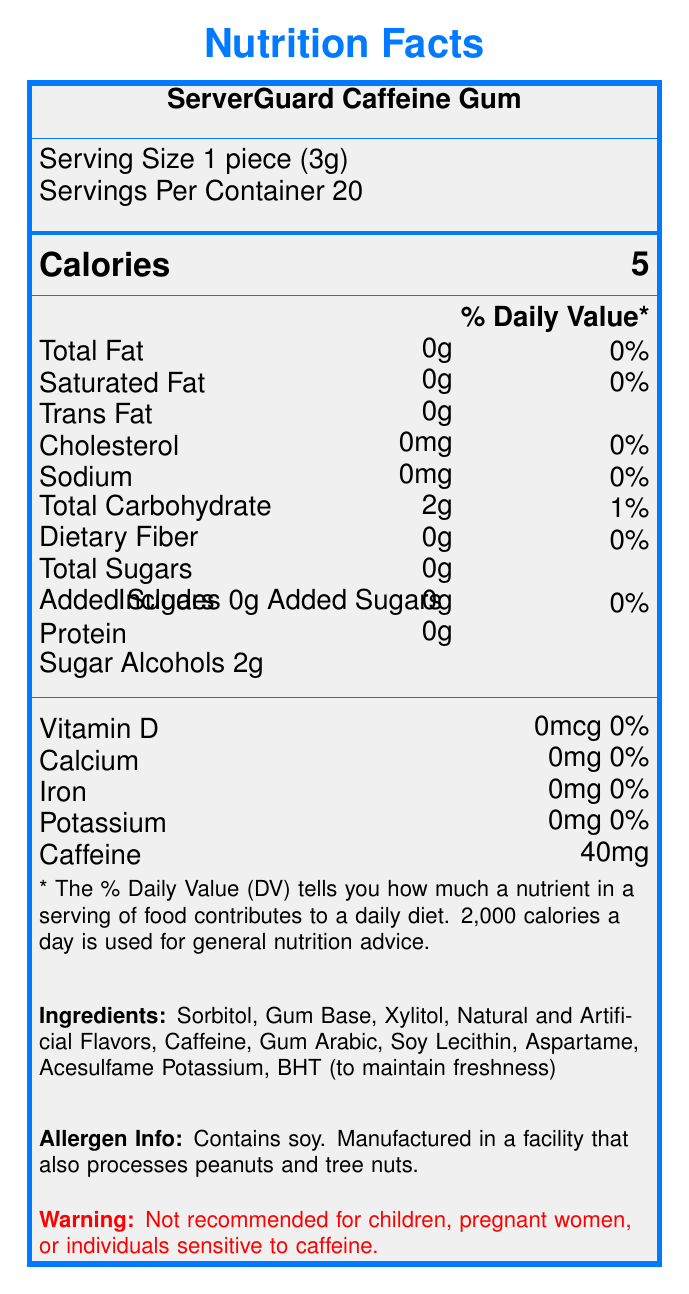what is the serving size of ServerGuard Caffeine Gum? The serving size is mentioned under the "Serving Size" section of the document.
Answer: 1 piece (3g) how many calories are in one piece of ServerGuard Caffeine Gum? The calorie count is listed under the "Calories" section with a bold text format.
Answer: 5 what percentage of Daily Value of total fat does ServerGuard Caffeine Gum have? The Daily Value percentage of total fat is listed as 0% in the nutrient information section of the document.
Answer: 0% how much caffeine is in a single piece of this gum? The amount of caffeine per piece is listed in the vitamin and mineral information section of the document.
Answer: 40mg what are the allergens present in ServerGuard Caffeine Gum? The allergen information is provided in the allergen info section of the document.
Answer: Contains soy. Manufactured in a facility that also processes peanuts and tree nuts. which certification does this product have? A. FDA Approved B. USDA Organic C. Fair Trade Certified D. Vegan The certifications section lists "FDA Approved" and "ISO 9001:2015 Certified".
Answer: A. FDA Approved which of the following is a claimed benefit of ServerGuard Caffeine Gum? i. Boosts alertness during late-night shifts ii. Provides essential vitamins iii. Contains natural flavors iv. Aids in weight loss The marketing claims section states that the gum "Boosts alertness during late-night server monitoring".
Answer: i. Boosts alertness during late-night shifts is it safe for children to consume ServerGuard Caffeine Gum? The warning section explicitly mentions that it is not recommended for children.
Answer: No describe the main idea of this document. The document provides comprehensive information about a caffeine-infused gum, including nutritional details, ingredients, and other essential product information designed for the target audience of IT professionals.
Answer: The document details the nutrition facts and additional information about ServerGuard Caffeine Gum, a product designed for IT professionals. It includes serving size, ingredients, allergen information, benefits, recommended use, storage instructions, and company details. can this product be stored in direct sunlight? The storage instructions section advises storing the product in a cool, dry place away from direct sunlight.
Answer: No what is the contact email for TechFuel Innovations? The company info section lists the contact email as support@techfuelinnovations.com.
Answer: support@techfuelinnovations.com how many grams of sugar alcohols are in one serving? The nutrient information section lists 2 grams of sugar alcohols per serving.
Answer: 2g how many servings are there per container? The serving information section specifies that there are 20 servings per container.
Answer: 20 how many pieces of gum should not be exceeded per day according to the recommended use? The recommended use section advises not to exceed 8 pieces per day.
Answer: 8 pieces are there any vitamins in ServerGuard Caffeine Gum? The vitamin and mineral information section lists 0% for Vitamin D, Calcium, Iron, and Potassium, indicating no vitamins are present.
Answer: No for what sort of professionals is ServerGuard Caffeine Gum designed? The marketing claims specify that the gum is designed for IT professionals.
Answer: IT professionals what daily calorie intake is the % Daily Value based on? The footnote mentions that the % Daily Value is based on a 2,000 calories per day diet.
Answer: 2,000 calories what additive is used to maintain freshness in ServerGuard Caffeine Gum? The ingredients section lists "BHT (to maintain freshness)".
Answer: BHT what is the source of protein in ServerGuard Caffeine Gum? The document lists 0g of protein without mentioning any source of protein.
Answer: Not enough information 